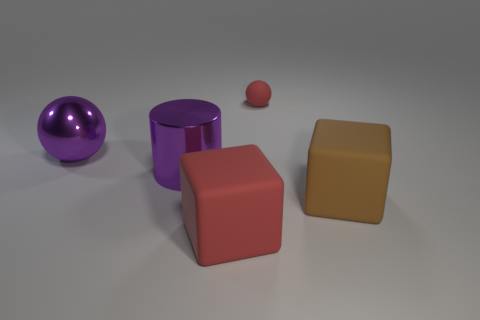How many red rubber cubes are to the left of the big purple thing in front of the big purple shiny ball?
Ensure brevity in your answer.  0. What is the size of the red ball that is the same material as the red cube?
Provide a short and direct response. Small. What is the size of the red sphere?
Your answer should be compact. Small. Is the material of the tiny red object the same as the big brown block?
Ensure brevity in your answer.  Yes. What number of spheres are small objects or large metal objects?
Provide a short and direct response. 2. What color is the rubber block that is left of the large object on the right side of the tiny thing?
Offer a very short reply. Red. There is a matte thing that is the same color as the tiny matte sphere; what size is it?
Offer a very short reply. Large. What number of big objects are behind the big thing in front of the large brown matte block in front of the purple cylinder?
Give a very brief answer. 3. Do the big thing that is on the right side of the tiny red matte sphere and the red matte object in front of the large brown matte object have the same shape?
Provide a short and direct response. Yes. What number of objects are either large blue blocks or balls?
Make the answer very short. 2. 